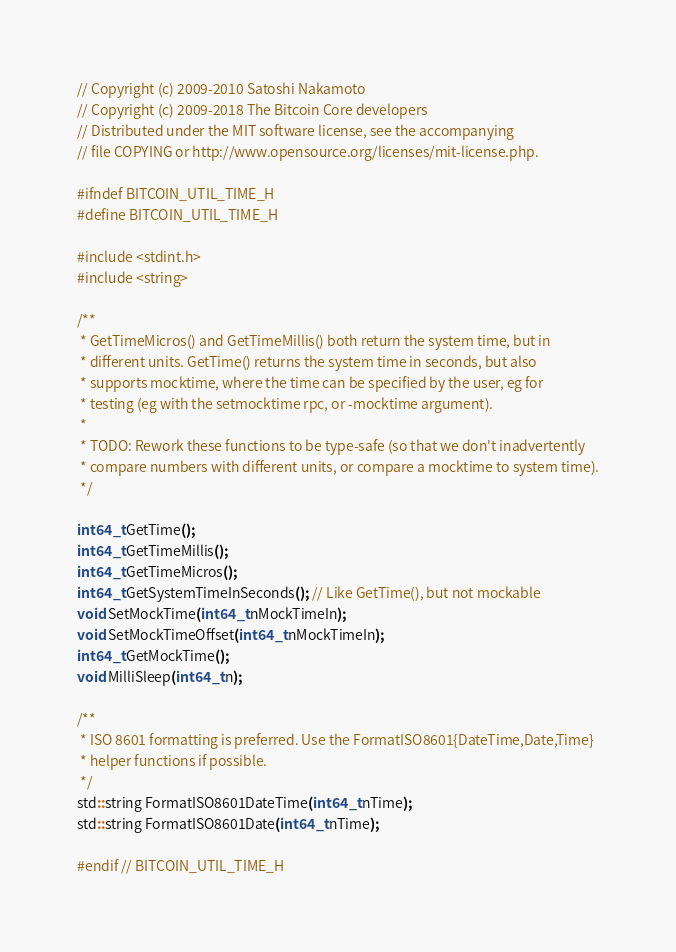Convert code to text. <code><loc_0><loc_0><loc_500><loc_500><_C_>// Copyright (c) 2009-2010 Satoshi Nakamoto
// Copyright (c) 2009-2018 The Bitcoin Core developers
// Distributed under the MIT software license, see the accompanying
// file COPYING or http://www.opensource.org/licenses/mit-license.php.

#ifndef BITCOIN_UTIL_TIME_H
#define BITCOIN_UTIL_TIME_H

#include <stdint.h>
#include <string>

/**
 * GetTimeMicros() and GetTimeMillis() both return the system time, but in
 * different units. GetTime() returns the system time in seconds, but also
 * supports mocktime, where the time can be specified by the user, eg for
 * testing (eg with the setmocktime rpc, or -mocktime argument).
 *
 * TODO: Rework these functions to be type-safe (so that we don't inadvertently
 * compare numbers with different units, or compare a mocktime to system time).
 */

int64_t GetTime();
int64_t GetTimeMillis();
int64_t GetTimeMicros();
int64_t GetSystemTimeInSeconds(); // Like GetTime(), but not mockable
void SetMockTime(int64_t nMockTimeIn);
void SetMockTimeOffset(int64_t nMockTimeIn);
int64_t GetMockTime();
void MilliSleep(int64_t n);

/**
 * ISO 8601 formatting is preferred. Use the FormatISO8601{DateTime,Date,Time}
 * helper functions if possible.
 */
std::string FormatISO8601DateTime(int64_t nTime);
std::string FormatISO8601Date(int64_t nTime);

#endif // BITCOIN_UTIL_TIME_H
</code> 